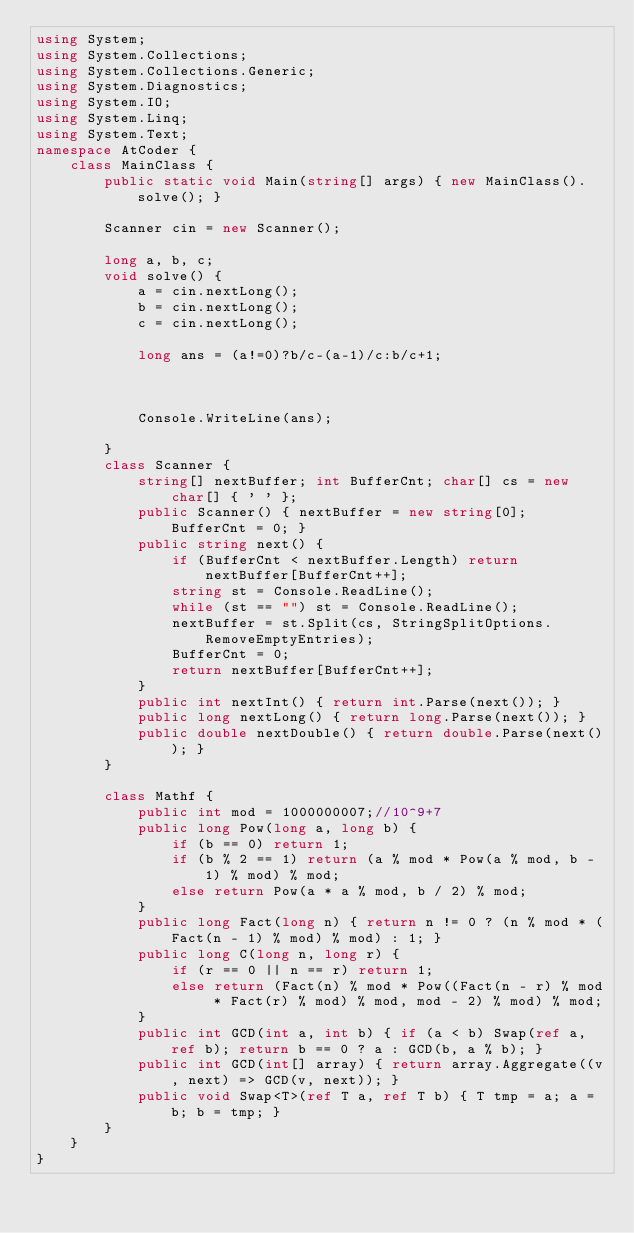Convert code to text. <code><loc_0><loc_0><loc_500><loc_500><_C#_>using System;
using System.Collections;
using System.Collections.Generic;
using System.Diagnostics;
using System.IO;
using System.Linq;
using System.Text;
namespace AtCoder {
    class MainClass {
        public static void Main(string[] args) { new MainClass().solve(); }

        Scanner cin = new Scanner();

        long a, b, c;
        void solve() {
            a = cin.nextLong();
            b = cin.nextLong();
            c = cin.nextLong();

            long ans = (a!=0)?b/c-(a-1)/c:b/c+1;



            Console.WriteLine(ans);

        }
        class Scanner {
            string[] nextBuffer; int BufferCnt; char[] cs = new char[] { ' ' };
            public Scanner() { nextBuffer = new string[0]; BufferCnt = 0; }
            public string next() {
                if (BufferCnt < nextBuffer.Length) return nextBuffer[BufferCnt++];
                string st = Console.ReadLine();
                while (st == "") st = Console.ReadLine();
                nextBuffer = st.Split(cs, StringSplitOptions.RemoveEmptyEntries);
                BufferCnt = 0;
                return nextBuffer[BufferCnt++];
            }
            public int nextInt() { return int.Parse(next()); }
            public long nextLong() { return long.Parse(next()); }
            public double nextDouble() { return double.Parse(next()); }
        }

        class Mathf {
            public int mod = 1000000007;//10^9+7
            public long Pow(long a, long b) {
                if (b == 0) return 1;
                if (b % 2 == 1) return (a % mod * Pow(a % mod, b - 1) % mod) % mod;
                else return Pow(a * a % mod, b / 2) % mod;
            }
            public long Fact(long n) { return n != 0 ? (n % mod * (Fact(n - 1) % mod) % mod) : 1; }
            public long C(long n, long r) {
                if (r == 0 || n == r) return 1;
                else return (Fact(n) % mod * Pow((Fact(n - r) % mod * Fact(r) % mod) % mod, mod - 2) % mod) % mod;
            }
            public int GCD(int a, int b) { if (a < b) Swap(ref a, ref b); return b == 0 ? a : GCD(b, a % b); }
            public int GCD(int[] array) { return array.Aggregate((v, next) => GCD(v, next)); }
            public void Swap<T>(ref T a, ref T b) { T tmp = a; a = b; b = tmp; }
        }
    }
}</code> 